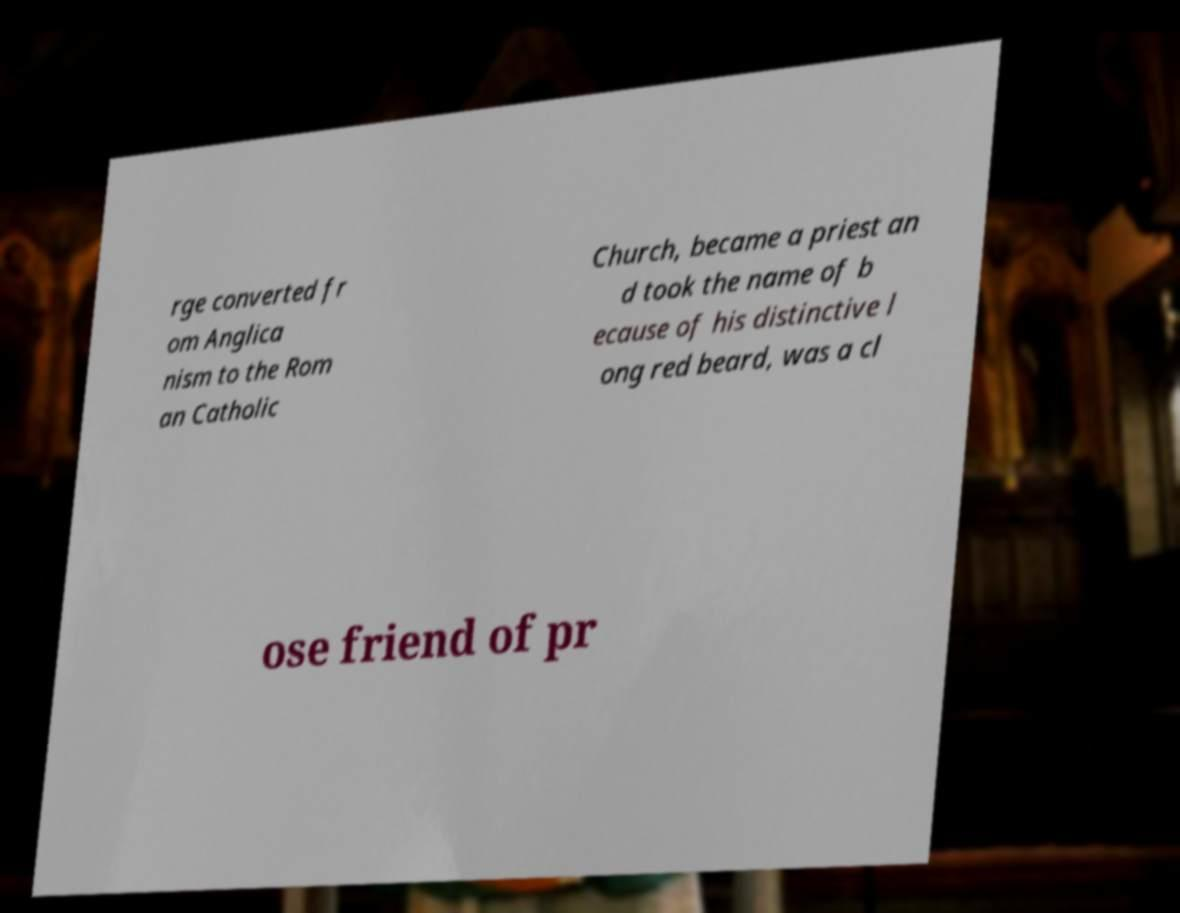Please identify and transcribe the text found in this image. rge converted fr om Anglica nism to the Rom an Catholic Church, became a priest an d took the name of b ecause of his distinctive l ong red beard, was a cl ose friend of pr 